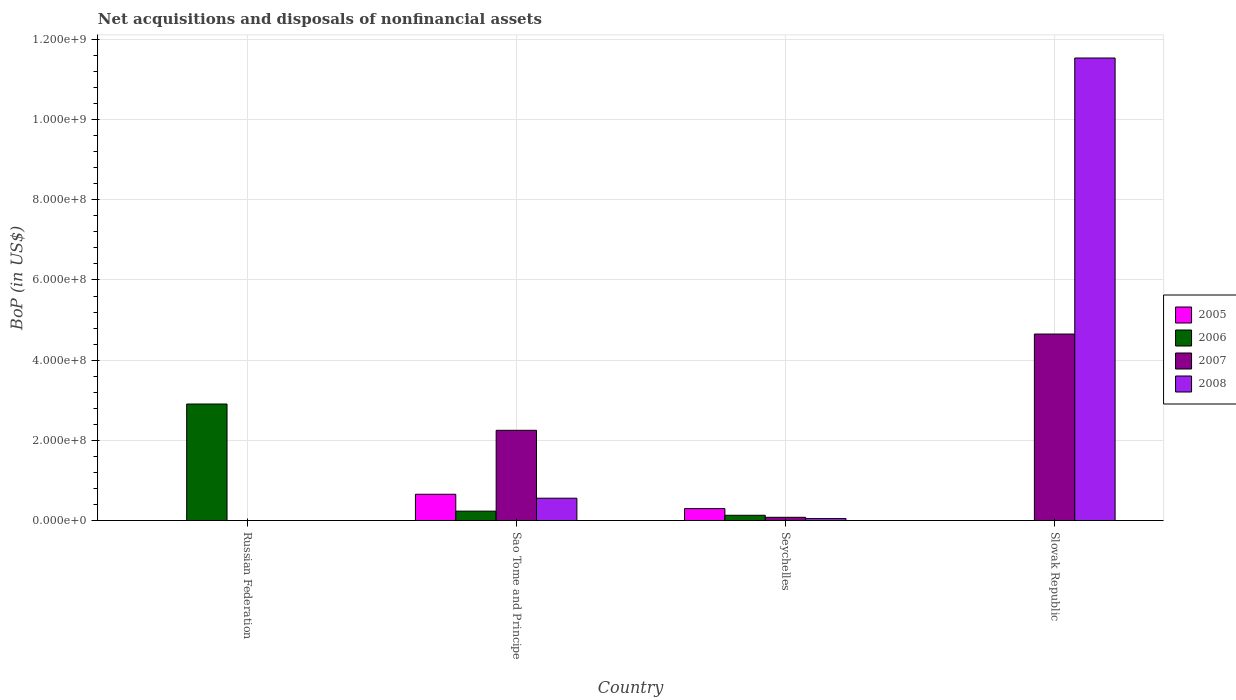How many different coloured bars are there?
Offer a very short reply. 4. Are the number of bars per tick equal to the number of legend labels?
Provide a short and direct response. No. What is the label of the 4th group of bars from the left?
Ensure brevity in your answer.  Slovak Republic. In how many cases, is the number of bars for a given country not equal to the number of legend labels?
Provide a short and direct response. 2. What is the Balance of Payments in 2006 in Russian Federation?
Your answer should be very brief. 2.91e+08. Across all countries, what is the maximum Balance of Payments in 2006?
Your answer should be very brief. 2.91e+08. In which country was the Balance of Payments in 2006 maximum?
Your answer should be compact. Russian Federation. What is the total Balance of Payments in 2006 in the graph?
Your answer should be very brief. 3.27e+08. What is the difference between the Balance of Payments in 2007 in Sao Tome and Principe and that in Seychelles?
Give a very brief answer. 2.17e+08. What is the difference between the Balance of Payments in 2005 in Seychelles and the Balance of Payments in 2007 in Russian Federation?
Ensure brevity in your answer.  2.99e+07. What is the average Balance of Payments in 2006 per country?
Provide a short and direct response. 8.19e+07. What is the difference between the Balance of Payments of/in 2008 and Balance of Payments of/in 2005 in Seychelles?
Provide a short and direct response. -2.48e+07. In how many countries, is the Balance of Payments in 2008 greater than 280000000 US$?
Offer a terse response. 1. What is the ratio of the Balance of Payments in 2008 in Seychelles to that in Slovak Republic?
Your response must be concise. 0. Is the Balance of Payments in 2008 in Sao Tome and Principe less than that in Slovak Republic?
Keep it short and to the point. Yes. What is the difference between the highest and the second highest Balance of Payments in 2008?
Provide a short and direct response. 1.15e+09. What is the difference between the highest and the lowest Balance of Payments in 2007?
Provide a short and direct response. 4.65e+08. In how many countries, is the Balance of Payments in 2005 greater than the average Balance of Payments in 2005 taken over all countries?
Offer a terse response. 2. Is it the case that in every country, the sum of the Balance of Payments in 2007 and Balance of Payments in 2005 is greater than the sum of Balance of Payments in 2006 and Balance of Payments in 2008?
Offer a terse response. No. Are all the bars in the graph horizontal?
Offer a terse response. No. What is the difference between two consecutive major ticks on the Y-axis?
Keep it short and to the point. 2.00e+08. Does the graph contain any zero values?
Provide a short and direct response. Yes. Does the graph contain grids?
Provide a short and direct response. Yes. How are the legend labels stacked?
Offer a terse response. Vertical. What is the title of the graph?
Give a very brief answer. Net acquisitions and disposals of nonfinancial assets. Does "1979" appear as one of the legend labels in the graph?
Make the answer very short. No. What is the label or title of the X-axis?
Your answer should be compact. Country. What is the label or title of the Y-axis?
Offer a terse response. BoP (in US$). What is the BoP (in US$) of 2006 in Russian Federation?
Offer a terse response. 2.91e+08. What is the BoP (in US$) of 2007 in Russian Federation?
Make the answer very short. 0. What is the BoP (in US$) of 2008 in Russian Federation?
Offer a very short reply. 0. What is the BoP (in US$) in 2005 in Sao Tome and Principe?
Offer a very short reply. 6.56e+07. What is the BoP (in US$) in 2006 in Sao Tome and Principe?
Your response must be concise. 2.35e+07. What is the BoP (in US$) in 2007 in Sao Tome and Principe?
Offer a very short reply. 2.25e+08. What is the BoP (in US$) in 2008 in Sao Tome and Principe?
Ensure brevity in your answer.  5.58e+07. What is the BoP (in US$) of 2005 in Seychelles?
Your response must be concise. 2.99e+07. What is the BoP (in US$) in 2006 in Seychelles?
Make the answer very short. 1.32e+07. What is the BoP (in US$) in 2007 in Seychelles?
Your answer should be compact. 8.17e+06. What is the BoP (in US$) of 2008 in Seychelles?
Offer a terse response. 5.04e+06. What is the BoP (in US$) in 2007 in Slovak Republic?
Offer a very short reply. 4.65e+08. What is the BoP (in US$) in 2008 in Slovak Republic?
Give a very brief answer. 1.15e+09. Across all countries, what is the maximum BoP (in US$) of 2005?
Provide a short and direct response. 6.56e+07. Across all countries, what is the maximum BoP (in US$) in 2006?
Your response must be concise. 2.91e+08. Across all countries, what is the maximum BoP (in US$) in 2007?
Offer a very short reply. 4.65e+08. Across all countries, what is the maximum BoP (in US$) of 2008?
Your answer should be compact. 1.15e+09. Across all countries, what is the minimum BoP (in US$) of 2005?
Your answer should be very brief. 0. Across all countries, what is the minimum BoP (in US$) of 2008?
Your response must be concise. 0. What is the total BoP (in US$) in 2005 in the graph?
Your answer should be very brief. 9.55e+07. What is the total BoP (in US$) in 2006 in the graph?
Offer a terse response. 3.27e+08. What is the total BoP (in US$) in 2007 in the graph?
Your response must be concise. 6.98e+08. What is the total BoP (in US$) of 2008 in the graph?
Provide a succinct answer. 1.21e+09. What is the difference between the BoP (in US$) in 2006 in Russian Federation and that in Sao Tome and Principe?
Make the answer very short. 2.67e+08. What is the difference between the BoP (in US$) of 2006 in Russian Federation and that in Seychelles?
Ensure brevity in your answer.  2.77e+08. What is the difference between the BoP (in US$) of 2005 in Sao Tome and Principe and that in Seychelles?
Offer a very short reply. 3.58e+07. What is the difference between the BoP (in US$) of 2006 in Sao Tome and Principe and that in Seychelles?
Ensure brevity in your answer.  1.03e+07. What is the difference between the BoP (in US$) in 2007 in Sao Tome and Principe and that in Seychelles?
Ensure brevity in your answer.  2.17e+08. What is the difference between the BoP (in US$) of 2008 in Sao Tome and Principe and that in Seychelles?
Offer a very short reply. 5.07e+07. What is the difference between the BoP (in US$) in 2007 in Sao Tome and Principe and that in Slovak Republic?
Offer a terse response. -2.40e+08. What is the difference between the BoP (in US$) in 2008 in Sao Tome and Principe and that in Slovak Republic?
Ensure brevity in your answer.  -1.10e+09. What is the difference between the BoP (in US$) of 2007 in Seychelles and that in Slovak Republic?
Provide a succinct answer. -4.57e+08. What is the difference between the BoP (in US$) of 2008 in Seychelles and that in Slovak Republic?
Keep it short and to the point. -1.15e+09. What is the difference between the BoP (in US$) of 2006 in Russian Federation and the BoP (in US$) of 2007 in Sao Tome and Principe?
Provide a short and direct response. 6.55e+07. What is the difference between the BoP (in US$) of 2006 in Russian Federation and the BoP (in US$) of 2008 in Sao Tome and Principe?
Offer a very short reply. 2.35e+08. What is the difference between the BoP (in US$) in 2006 in Russian Federation and the BoP (in US$) in 2007 in Seychelles?
Provide a short and direct response. 2.82e+08. What is the difference between the BoP (in US$) of 2006 in Russian Federation and the BoP (in US$) of 2008 in Seychelles?
Give a very brief answer. 2.86e+08. What is the difference between the BoP (in US$) in 2006 in Russian Federation and the BoP (in US$) in 2007 in Slovak Republic?
Provide a succinct answer. -1.75e+08. What is the difference between the BoP (in US$) in 2006 in Russian Federation and the BoP (in US$) in 2008 in Slovak Republic?
Provide a short and direct response. -8.63e+08. What is the difference between the BoP (in US$) of 2005 in Sao Tome and Principe and the BoP (in US$) of 2006 in Seychelles?
Provide a succinct answer. 5.24e+07. What is the difference between the BoP (in US$) in 2005 in Sao Tome and Principe and the BoP (in US$) in 2007 in Seychelles?
Keep it short and to the point. 5.75e+07. What is the difference between the BoP (in US$) of 2005 in Sao Tome and Principe and the BoP (in US$) of 2008 in Seychelles?
Make the answer very short. 6.06e+07. What is the difference between the BoP (in US$) of 2006 in Sao Tome and Principe and the BoP (in US$) of 2007 in Seychelles?
Keep it short and to the point. 1.54e+07. What is the difference between the BoP (in US$) of 2006 in Sao Tome and Principe and the BoP (in US$) of 2008 in Seychelles?
Your answer should be compact. 1.85e+07. What is the difference between the BoP (in US$) in 2007 in Sao Tome and Principe and the BoP (in US$) in 2008 in Seychelles?
Offer a very short reply. 2.20e+08. What is the difference between the BoP (in US$) in 2005 in Sao Tome and Principe and the BoP (in US$) in 2007 in Slovak Republic?
Offer a very short reply. -4.00e+08. What is the difference between the BoP (in US$) of 2005 in Sao Tome and Principe and the BoP (in US$) of 2008 in Slovak Republic?
Your answer should be compact. -1.09e+09. What is the difference between the BoP (in US$) in 2006 in Sao Tome and Principe and the BoP (in US$) in 2007 in Slovak Republic?
Ensure brevity in your answer.  -4.42e+08. What is the difference between the BoP (in US$) in 2006 in Sao Tome and Principe and the BoP (in US$) in 2008 in Slovak Republic?
Provide a succinct answer. -1.13e+09. What is the difference between the BoP (in US$) of 2007 in Sao Tome and Principe and the BoP (in US$) of 2008 in Slovak Republic?
Make the answer very short. -9.28e+08. What is the difference between the BoP (in US$) of 2005 in Seychelles and the BoP (in US$) of 2007 in Slovak Republic?
Your answer should be compact. -4.35e+08. What is the difference between the BoP (in US$) of 2005 in Seychelles and the BoP (in US$) of 2008 in Slovak Republic?
Give a very brief answer. -1.12e+09. What is the difference between the BoP (in US$) in 2006 in Seychelles and the BoP (in US$) in 2007 in Slovak Republic?
Provide a short and direct response. -4.52e+08. What is the difference between the BoP (in US$) in 2006 in Seychelles and the BoP (in US$) in 2008 in Slovak Republic?
Your answer should be compact. -1.14e+09. What is the difference between the BoP (in US$) in 2007 in Seychelles and the BoP (in US$) in 2008 in Slovak Republic?
Provide a short and direct response. -1.15e+09. What is the average BoP (in US$) of 2005 per country?
Keep it short and to the point. 2.39e+07. What is the average BoP (in US$) in 2006 per country?
Give a very brief answer. 8.19e+07. What is the average BoP (in US$) of 2007 per country?
Provide a short and direct response. 1.75e+08. What is the average BoP (in US$) in 2008 per country?
Your answer should be very brief. 3.04e+08. What is the difference between the BoP (in US$) of 2005 and BoP (in US$) of 2006 in Sao Tome and Principe?
Keep it short and to the point. 4.21e+07. What is the difference between the BoP (in US$) of 2005 and BoP (in US$) of 2007 in Sao Tome and Principe?
Keep it short and to the point. -1.59e+08. What is the difference between the BoP (in US$) of 2005 and BoP (in US$) of 2008 in Sao Tome and Principe?
Ensure brevity in your answer.  9.87e+06. What is the difference between the BoP (in US$) in 2006 and BoP (in US$) in 2007 in Sao Tome and Principe?
Offer a terse response. -2.02e+08. What is the difference between the BoP (in US$) in 2006 and BoP (in US$) in 2008 in Sao Tome and Principe?
Your answer should be compact. -3.22e+07. What is the difference between the BoP (in US$) in 2007 and BoP (in US$) in 2008 in Sao Tome and Principe?
Your answer should be compact. 1.69e+08. What is the difference between the BoP (in US$) of 2005 and BoP (in US$) of 2006 in Seychelles?
Offer a very short reply. 1.66e+07. What is the difference between the BoP (in US$) of 2005 and BoP (in US$) of 2007 in Seychelles?
Keep it short and to the point. 2.17e+07. What is the difference between the BoP (in US$) of 2005 and BoP (in US$) of 2008 in Seychelles?
Offer a terse response. 2.48e+07. What is the difference between the BoP (in US$) of 2006 and BoP (in US$) of 2007 in Seychelles?
Offer a terse response. 5.07e+06. What is the difference between the BoP (in US$) in 2006 and BoP (in US$) in 2008 in Seychelles?
Provide a short and direct response. 8.20e+06. What is the difference between the BoP (in US$) in 2007 and BoP (in US$) in 2008 in Seychelles?
Offer a very short reply. 3.13e+06. What is the difference between the BoP (in US$) in 2007 and BoP (in US$) in 2008 in Slovak Republic?
Make the answer very short. -6.88e+08. What is the ratio of the BoP (in US$) in 2006 in Russian Federation to that in Sao Tome and Principe?
Provide a succinct answer. 12.35. What is the ratio of the BoP (in US$) of 2006 in Russian Federation to that in Seychelles?
Ensure brevity in your answer.  21.95. What is the ratio of the BoP (in US$) of 2005 in Sao Tome and Principe to that in Seychelles?
Offer a very short reply. 2.2. What is the ratio of the BoP (in US$) in 2006 in Sao Tome and Principe to that in Seychelles?
Your answer should be very brief. 1.78. What is the ratio of the BoP (in US$) of 2007 in Sao Tome and Principe to that in Seychelles?
Offer a terse response. 27.55. What is the ratio of the BoP (in US$) of 2008 in Sao Tome and Principe to that in Seychelles?
Your response must be concise. 11.07. What is the ratio of the BoP (in US$) in 2007 in Sao Tome and Principe to that in Slovak Republic?
Offer a very short reply. 0.48. What is the ratio of the BoP (in US$) of 2008 in Sao Tome and Principe to that in Slovak Republic?
Provide a short and direct response. 0.05. What is the ratio of the BoP (in US$) of 2007 in Seychelles to that in Slovak Republic?
Your response must be concise. 0.02. What is the ratio of the BoP (in US$) of 2008 in Seychelles to that in Slovak Republic?
Offer a very short reply. 0. What is the difference between the highest and the second highest BoP (in US$) of 2006?
Make the answer very short. 2.67e+08. What is the difference between the highest and the second highest BoP (in US$) in 2007?
Give a very brief answer. 2.40e+08. What is the difference between the highest and the second highest BoP (in US$) of 2008?
Your answer should be compact. 1.10e+09. What is the difference between the highest and the lowest BoP (in US$) of 2005?
Offer a terse response. 6.56e+07. What is the difference between the highest and the lowest BoP (in US$) of 2006?
Provide a short and direct response. 2.91e+08. What is the difference between the highest and the lowest BoP (in US$) of 2007?
Offer a terse response. 4.65e+08. What is the difference between the highest and the lowest BoP (in US$) in 2008?
Ensure brevity in your answer.  1.15e+09. 